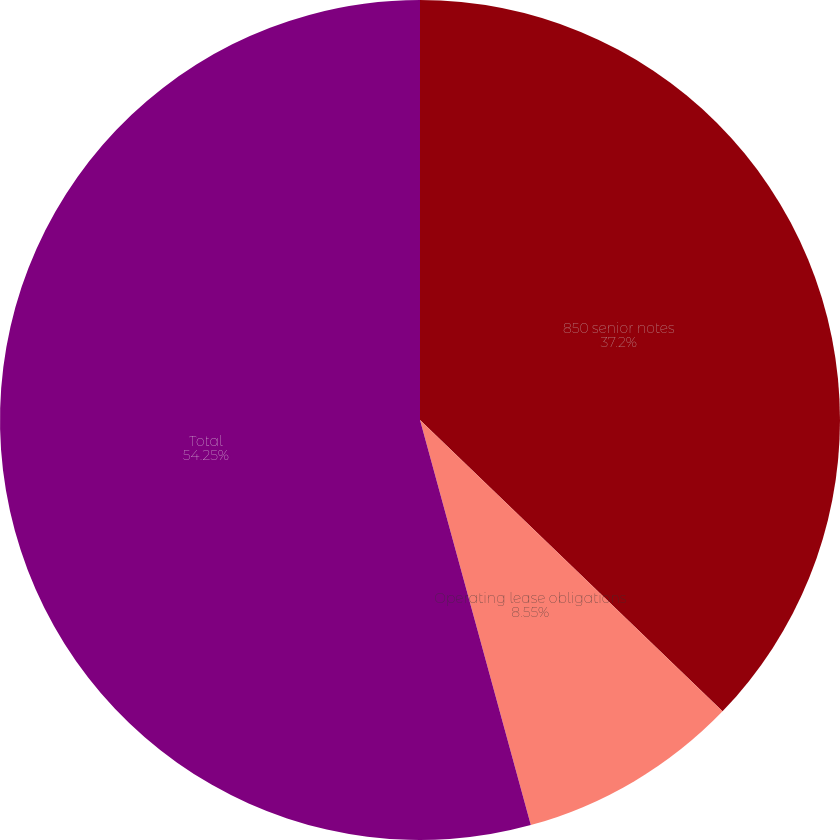Convert chart. <chart><loc_0><loc_0><loc_500><loc_500><pie_chart><fcel>850 senior notes<fcel>Operating lease obligations<fcel>Total<nl><fcel>37.2%<fcel>8.55%<fcel>54.25%<nl></chart> 